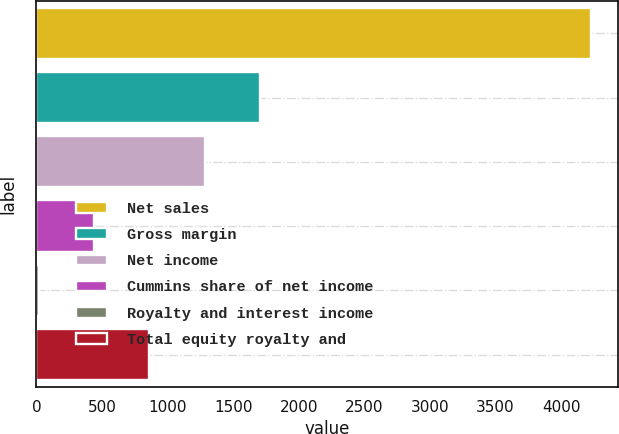<chart> <loc_0><loc_0><loc_500><loc_500><bar_chart><fcel>Net sales<fcel>Gross margin<fcel>Net income<fcel>Cummins share of net income<fcel>Royalty and interest income<fcel>Total equity royalty and<nl><fcel>4224<fcel>1702.2<fcel>1281.9<fcel>441.3<fcel>21<fcel>861.6<nl></chart> 